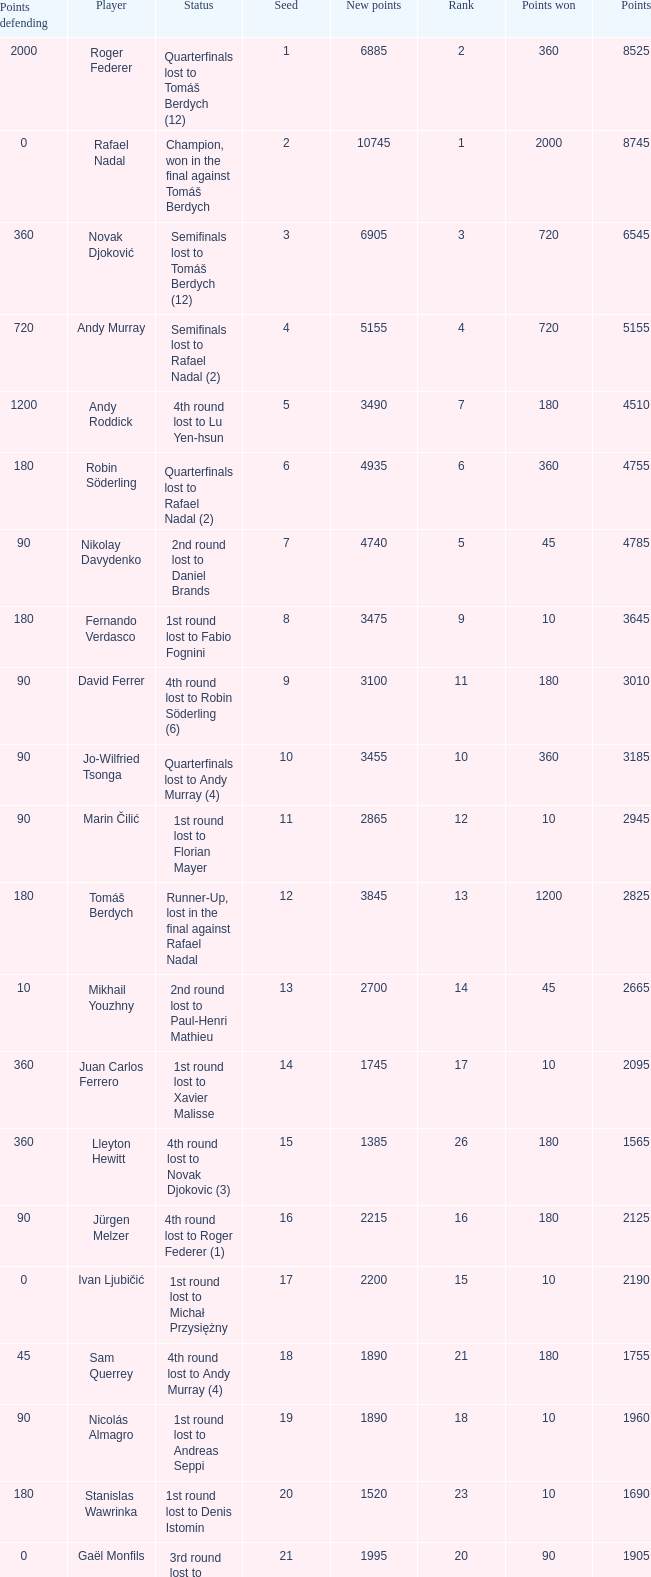Name the status for points 3185 Quarterfinals lost to Andy Murray (4). 